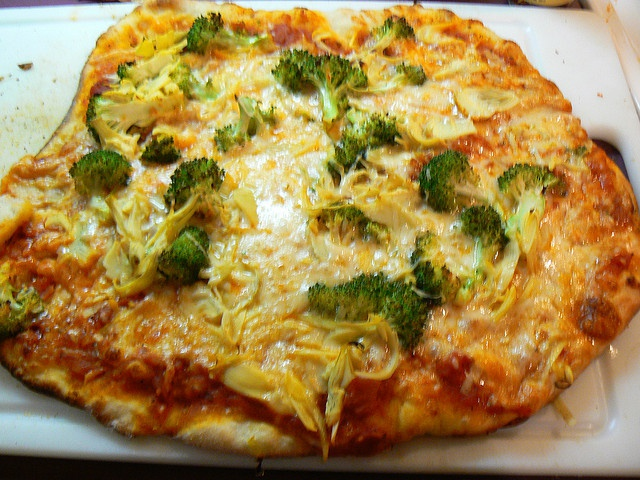Describe the objects in this image and their specific colors. I can see pizza in purple, olive, orange, maroon, and tan tones, broccoli in purple, olive, black, and darkgreen tones, broccoli in purple, olive, and khaki tones, broccoli in purple, olive, orange, khaki, and tan tones, and broccoli in purple, olive, and black tones in this image. 